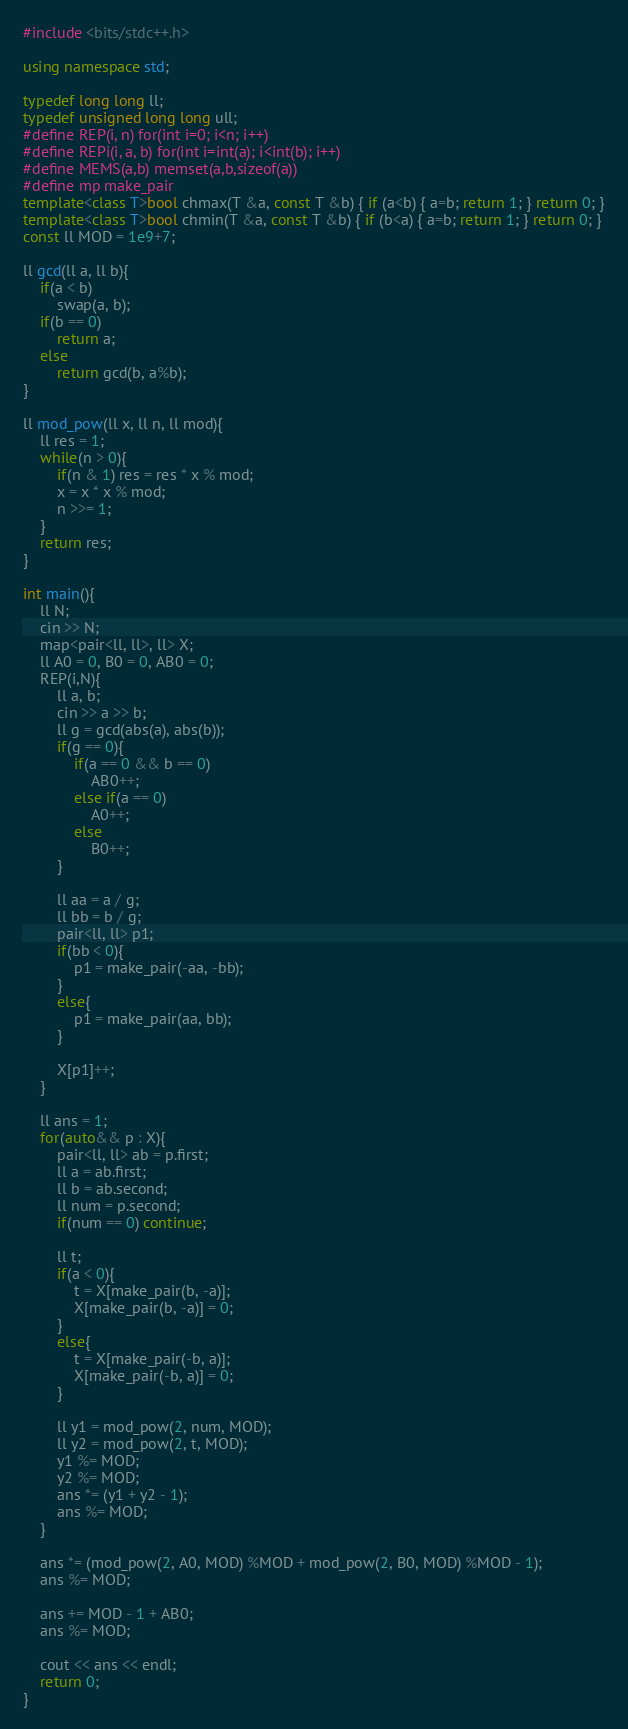Convert code to text. <code><loc_0><loc_0><loc_500><loc_500><_C++_>#include <bits/stdc++.h>

using namespace std;

typedef long long ll;
typedef unsigned long long ull;
#define REP(i, n) for(int i=0; i<n; i++)
#define REPi(i, a, b) for(int i=int(a); i<int(b); i++)
#define MEMS(a,b) memset(a,b,sizeof(a))
#define mp make_pair
template<class T>bool chmax(T &a, const T &b) { if (a<b) { a=b; return 1; } return 0; }
template<class T>bool chmin(T &a, const T &b) { if (b<a) { a=b; return 1; } return 0; }
const ll MOD = 1e9+7;

ll gcd(ll a, ll b){
    if(a < b)
        swap(a, b);
    if(b == 0)
        return a;
    else
        return gcd(b, a%b);
}

ll mod_pow(ll x, ll n, ll mod){
    ll res = 1;
    while(n > 0){
        if(n & 1) res = res * x % mod;
        x = x * x % mod;
        n >>= 1;
    }
    return res;
}

int main(){
    ll N;
    cin >> N;
    map<pair<ll, ll>, ll> X;
    ll A0 = 0, B0 = 0, AB0 = 0;
    REP(i,N){
        ll a, b;
        cin >> a >> b;
        ll g = gcd(abs(a), abs(b));
        if(g == 0){
            if(a == 0 && b == 0)
                AB0++;
            else if(a == 0)
                A0++;
            else
                B0++;
        }

        ll aa = a / g;
        ll bb = b / g;
        pair<ll, ll> p1;
        if(bb < 0){
            p1 = make_pair(-aa, -bb);
        }
        else{
            p1 = make_pair(aa, bb);
        }

        X[p1]++;
    }

    ll ans = 1;
    for(auto&& p : X){
        pair<ll, ll> ab = p.first;
        ll a = ab.first;
        ll b = ab.second;
        ll num = p.second;
        if(num == 0) continue;

        ll t;
        if(a < 0){
            t = X[make_pair(b, -a)];
            X[make_pair(b, -a)] = 0;
        }
        else{
            t = X[make_pair(-b, a)];
            X[make_pair(-b, a)] = 0;
        }

        ll y1 = mod_pow(2, num, MOD);
        ll y2 = mod_pow(2, t, MOD);
        y1 %= MOD;
        y2 %= MOD;
        ans *= (y1 + y2 - 1);
        ans %= MOD;
    }

    ans *= (mod_pow(2, A0, MOD) %MOD + mod_pow(2, B0, MOD) %MOD - 1);
    ans %= MOD;

    ans += MOD - 1 + AB0;
    ans %= MOD;

    cout << ans << endl;
    return 0;
}
</code> 